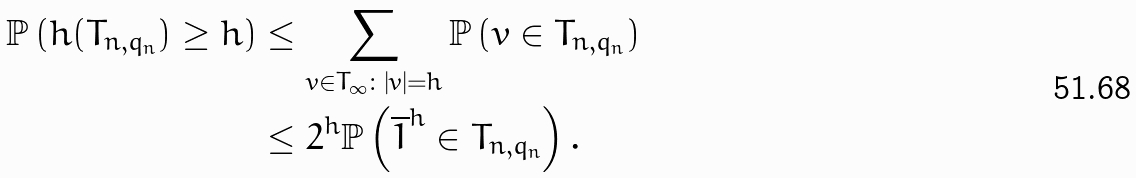<formula> <loc_0><loc_0><loc_500><loc_500>\mathbb { P } \left ( h ( T _ { n , q _ { n } } ) \geq h \right ) & \leq \sum _ { v \in T _ { \infty } \colon | v | = h } \mathbb { P } \left ( v \in T _ { n , q _ { n } } \right ) \\ & \leq 2 ^ { h } \mathbb { P } \left ( \overline { 1 } ^ { h } \in T _ { n , q _ { n } } \right ) .</formula> 